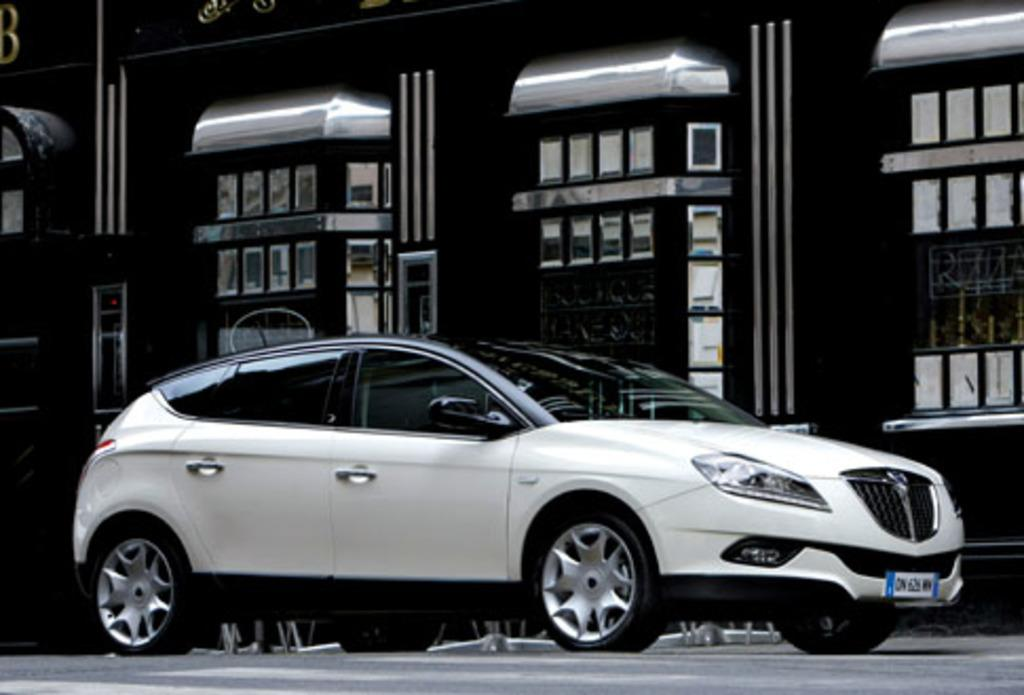What color is the car in the image? The car in the image is white. Where is the car located in the image? The car is parked on the roadside. What type of structure is visible in the image? There is a black color building in the image. What feature can be observed on the building? The building has glass windows. What other object can be seen in the image? There is a silver color canopy shed in the image. What type of spark can be seen coming from the car's exhaust in the image? There is no spark coming from the car's exhaust in the image, as the car is parked and not running. 